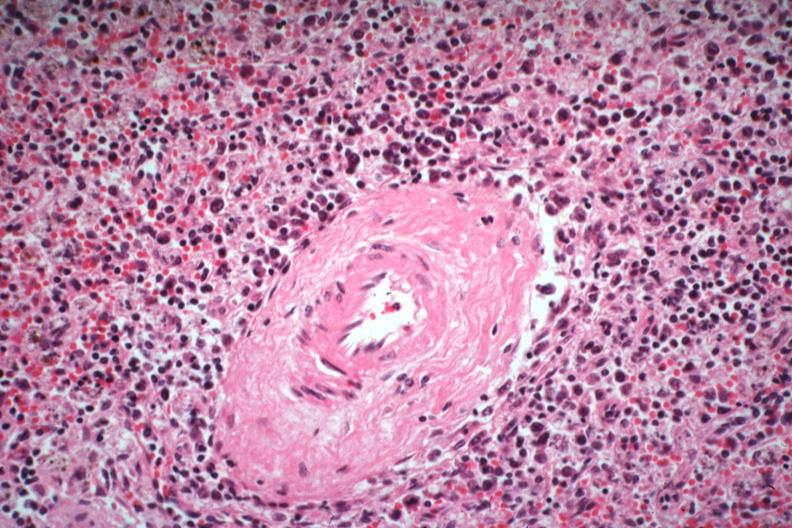what died of what was thought to be viral pneumonia probably influenza?
Answer the question using a single word or phrase. Atypical appearing immunoblastic cells near splenic arteriole man 